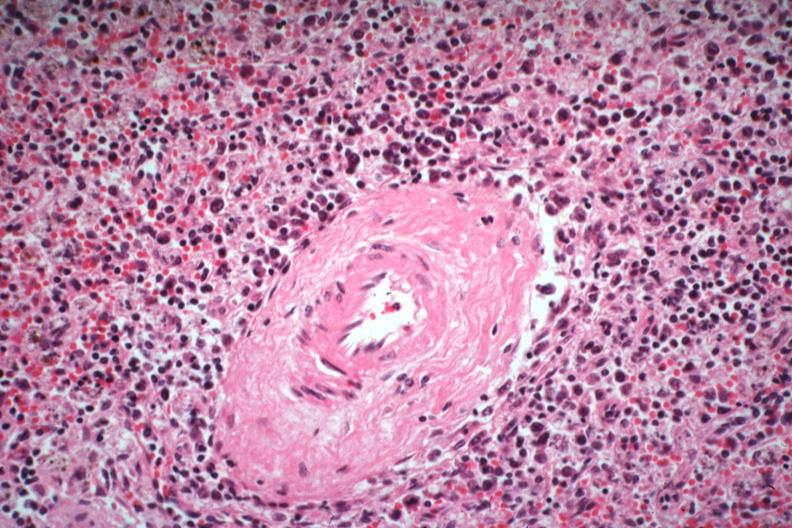what died of what was thought to be viral pneumonia probably influenza?
Answer the question using a single word or phrase. Atypical appearing immunoblastic cells near splenic arteriole man 